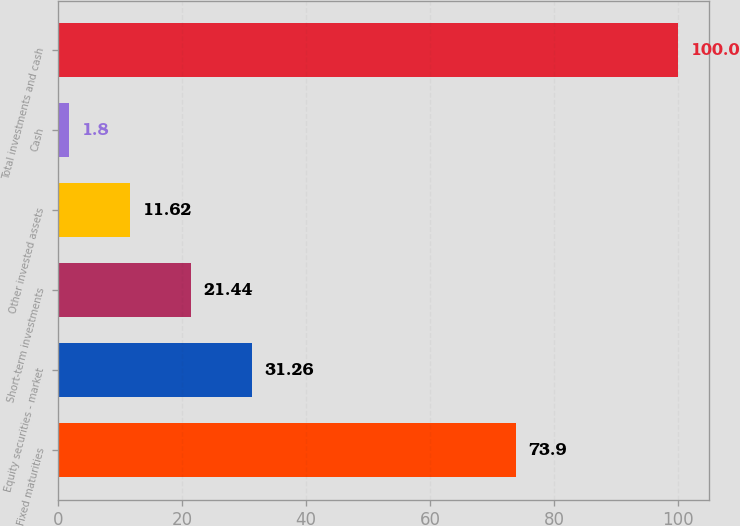Convert chart. <chart><loc_0><loc_0><loc_500><loc_500><bar_chart><fcel>Fixed maturities<fcel>Equity securities - market<fcel>Short-term investments<fcel>Other invested assets<fcel>Cash<fcel>Total investments and cash<nl><fcel>73.9<fcel>31.26<fcel>21.44<fcel>11.62<fcel>1.8<fcel>100<nl></chart> 